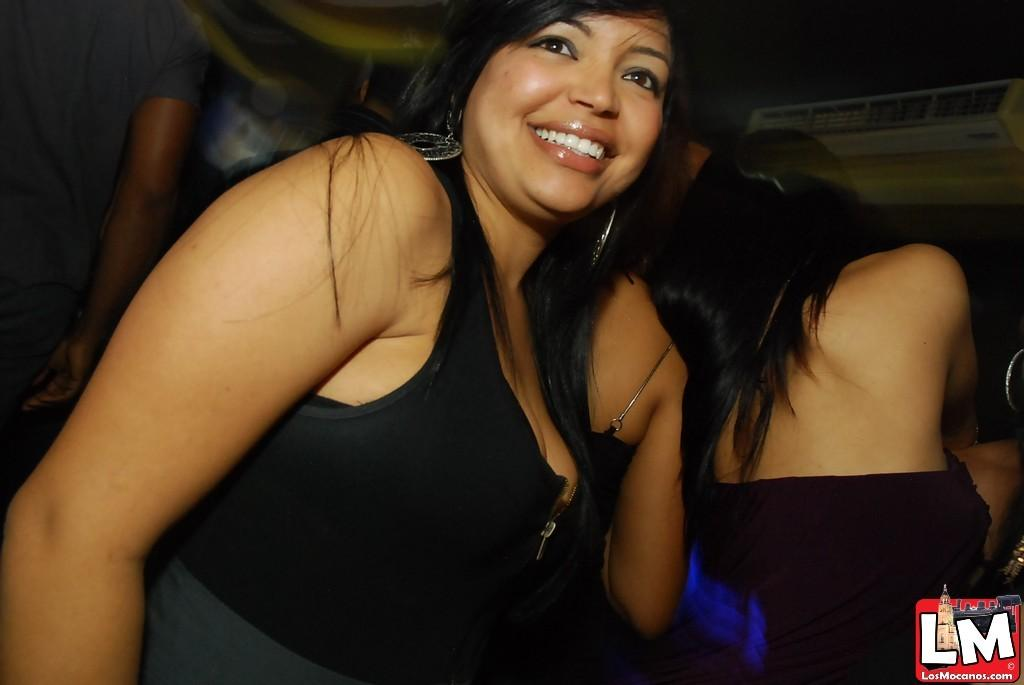How many women are in the image? There are two women in the image. What are the women wearing? Both women are wearing black dresses. What can be observed about the background of the image? The background of the image is dark. What type of action is the jar performing in the image? There is no jar present in the image, so it cannot perform any actions. 